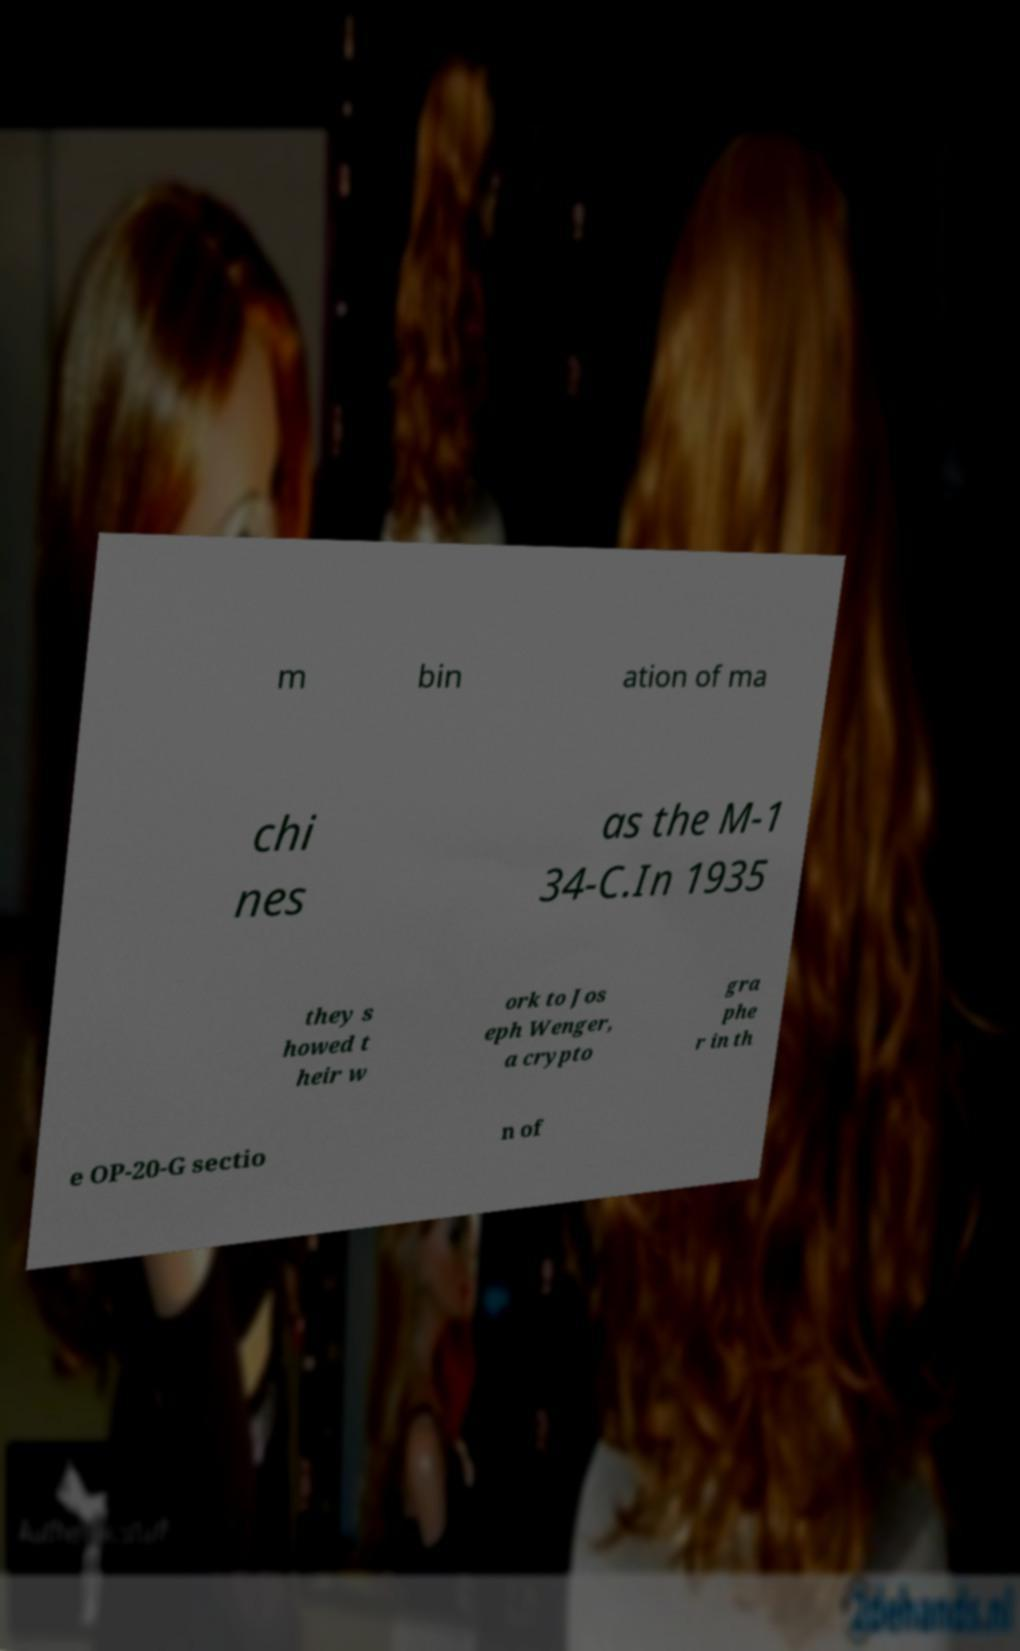Please identify and transcribe the text found in this image. m bin ation of ma chi nes as the M-1 34-C.In 1935 they s howed t heir w ork to Jos eph Wenger, a crypto gra phe r in th e OP-20-G sectio n of 